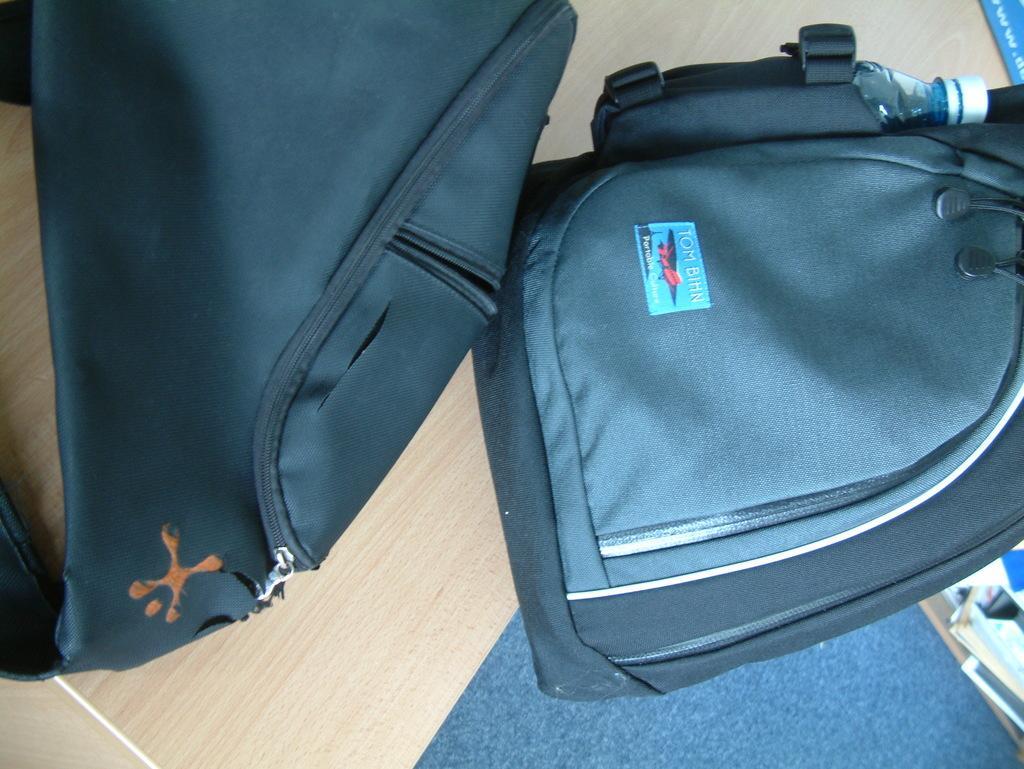In one or two sentences, can you explain what this image depicts? This is a picture of a backpack which is blue in color. 